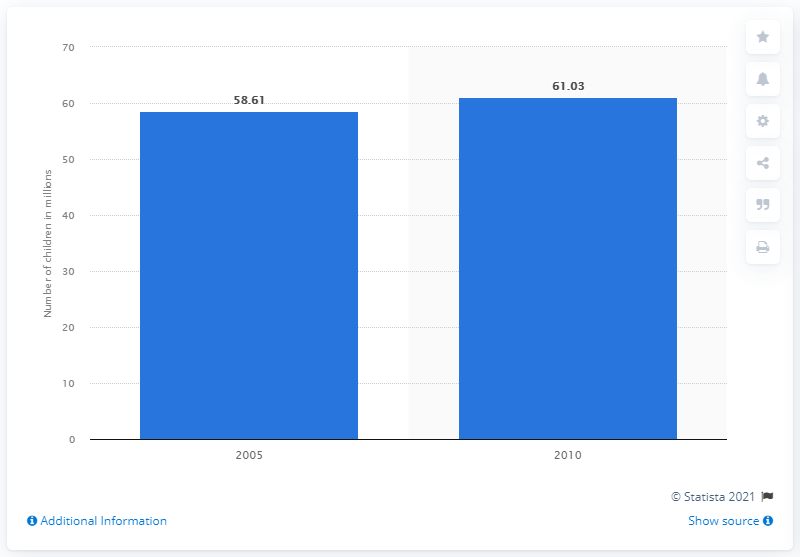List a handful of essential elements in this visual. According to the 6th National Population Census of the Republic of China, 61.03% of rural children grew up without their parents. 